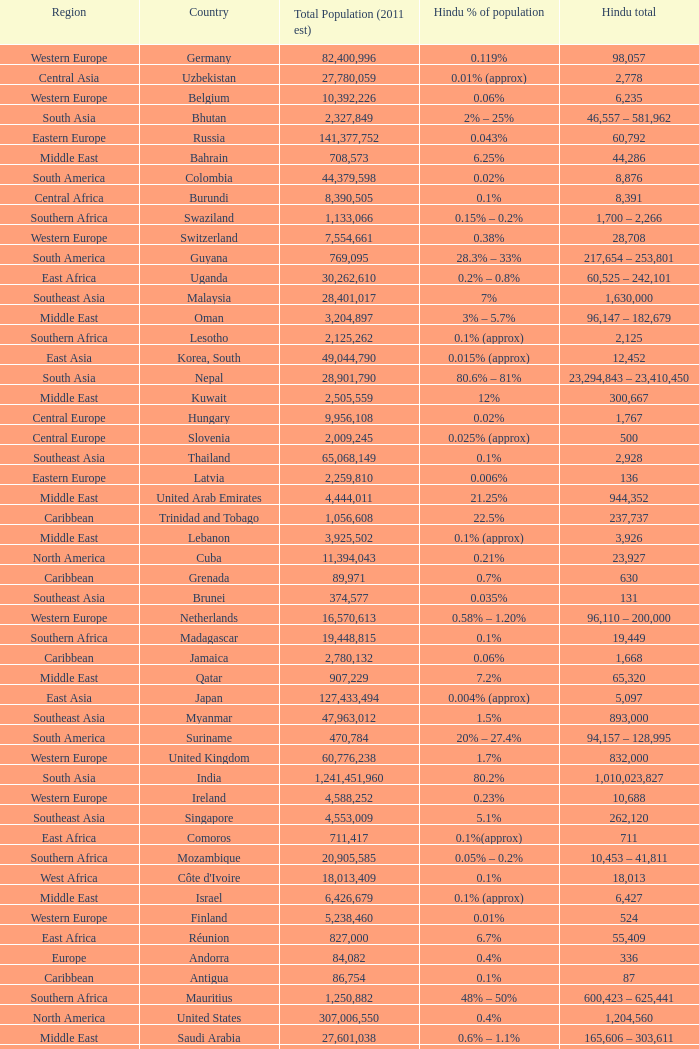Total Population (2011 est) larger than 30,262,610, and a Hindu total of 63,718 involves what country? France. 